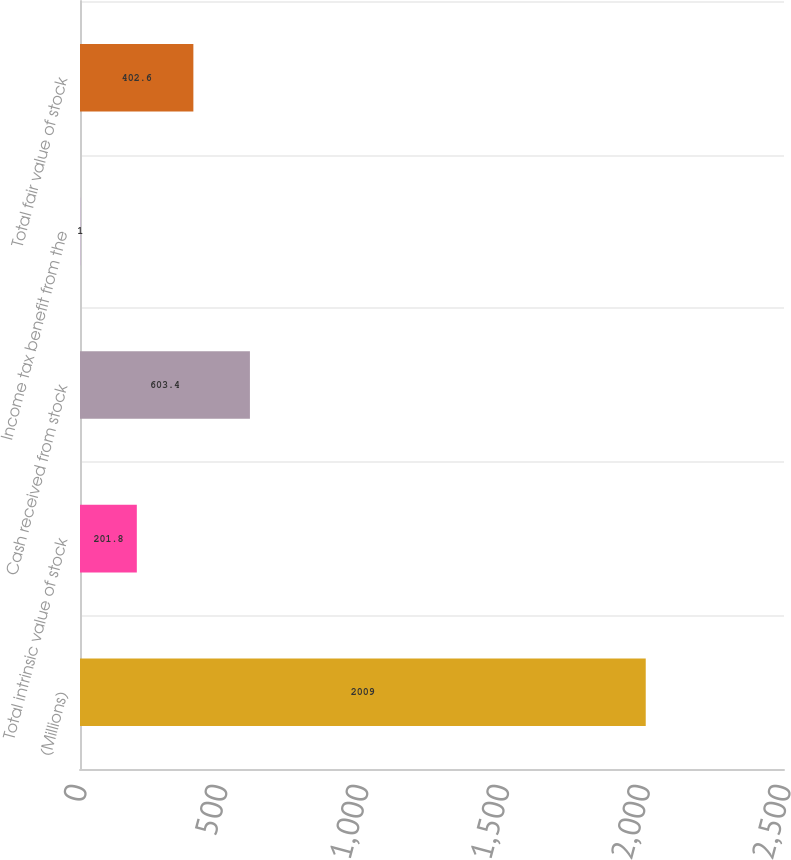Convert chart to OTSL. <chart><loc_0><loc_0><loc_500><loc_500><bar_chart><fcel>(Millions)<fcel>Total intrinsic value of stock<fcel>Cash received from stock<fcel>Income tax benefit from the<fcel>Total fair value of stock<nl><fcel>2009<fcel>201.8<fcel>603.4<fcel>1<fcel>402.6<nl></chart> 